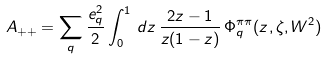<formula> <loc_0><loc_0><loc_500><loc_500>A _ { + + } = \sum _ { q } \frac { e _ { q } ^ { 2 } } { 2 } \int _ { 0 } ^ { 1 } \, d z \, { \frac { 2 z - 1 } { z ( 1 - z ) } } \, \Phi _ { q } ^ { \pi \pi } ( z , \zeta , W ^ { 2 } )</formula> 